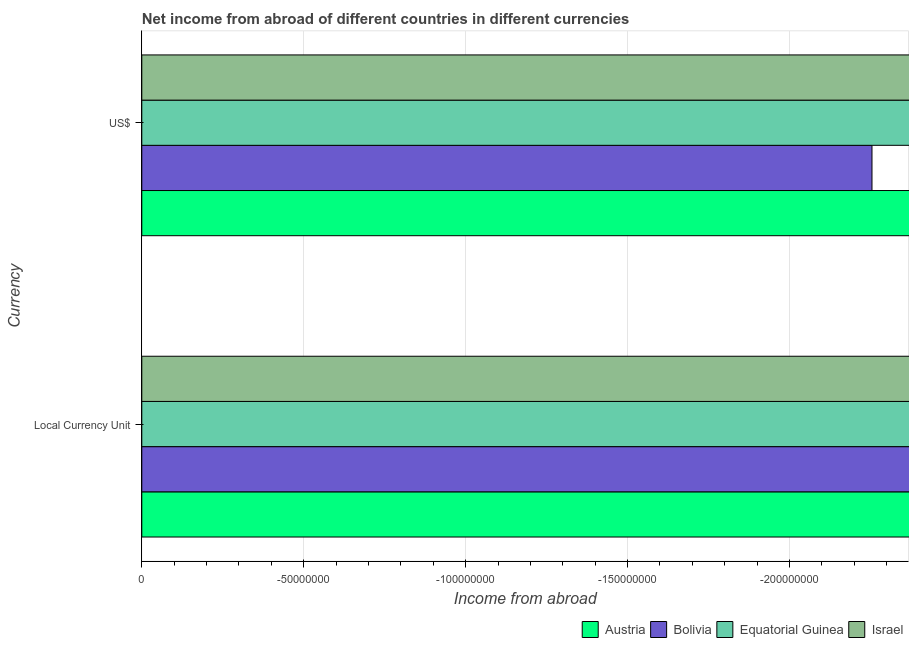How many different coloured bars are there?
Provide a short and direct response. 0. Are the number of bars per tick equal to the number of legend labels?
Make the answer very short. No. Are the number of bars on each tick of the Y-axis equal?
Keep it short and to the point. Yes. What is the label of the 1st group of bars from the top?
Your answer should be compact. US$. What is the income from abroad in us$ in Bolivia?
Offer a very short reply. 0. Across all countries, what is the minimum income from abroad in us$?
Make the answer very short. 0. What is the difference between the income from abroad in constant 2005 us$ in Israel and the income from abroad in us$ in Bolivia?
Your answer should be compact. 0. In how many countries, is the income from abroad in us$ greater than -190000000 units?
Your response must be concise. 0. How many bars are there?
Provide a succinct answer. 0. Are all the bars in the graph horizontal?
Give a very brief answer. Yes. What is the title of the graph?
Your answer should be compact. Net income from abroad of different countries in different currencies. What is the label or title of the X-axis?
Provide a succinct answer. Income from abroad. What is the label or title of the Y-axis?
Offer a terse response. Currency. What is the Income from abroad in Equatorial Guinea in US$?
Your answer should be very brief. 0. What is the average Income from abroad in Austria per Currency?
Make the answer very short. 0. What is the average Income from abroad in Bolivia per Currency?
Make the answer very short. 0. What is the average Income from abroad in Equatorial Guinea per Currency?
Offer a terse response. 0. What is the average Income from abroad in Israel per Currency?
Make the answer very short. 0. 